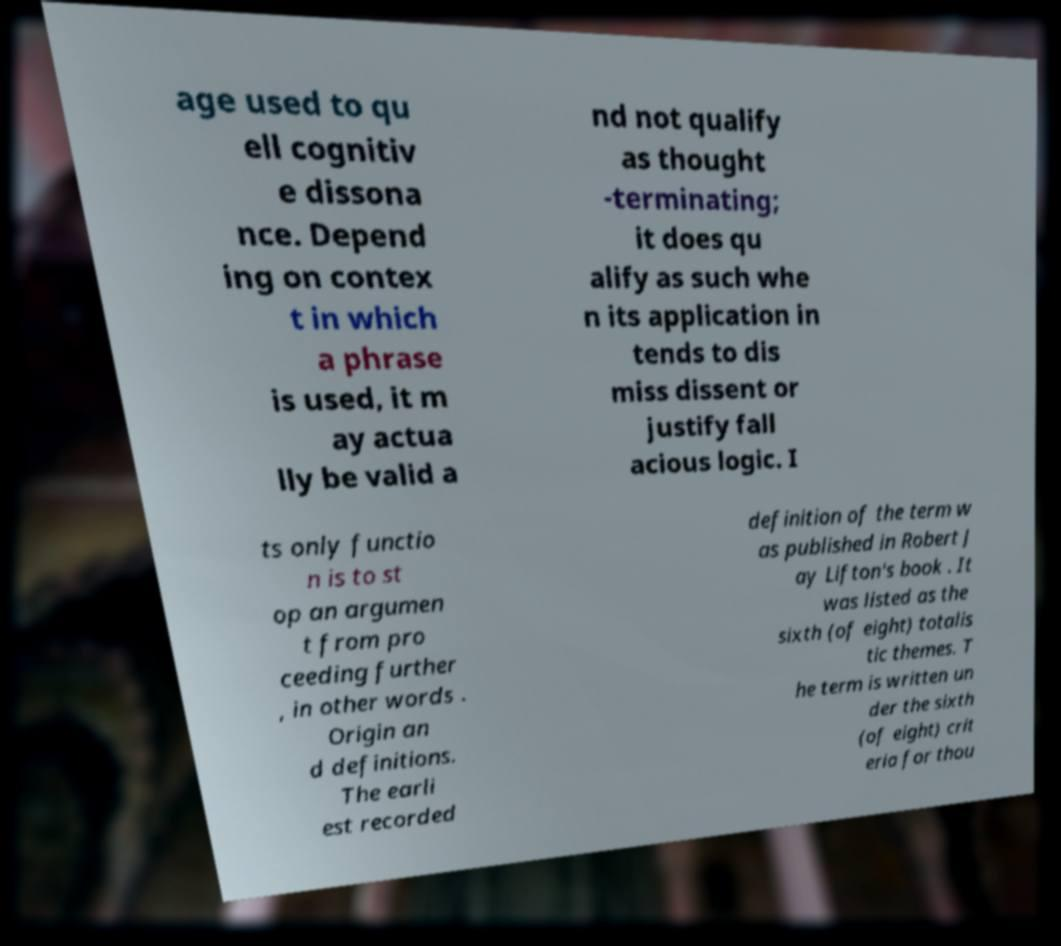Please identify and transcribe the text found in this image. age used to qu ell cognitiv e dissona nce. Depend ing on contex t in which a phrase is used, it m ay actua lly be valid a nd not qualify as thought -terminating; it does qu alify as such whe n its application in tends to dis miss dissent or justify fall acious logic. I ts only functio n is to st op an argumen t from pro ceeding further , in other words . Origin an d definitions. The earli est recorded definition of the term w as published in Robert J ay Lifton's book . It was listed as the sixth (of eight) totalis tic themes. T he term is written un der the sixth (of eight) crit eria for thou 